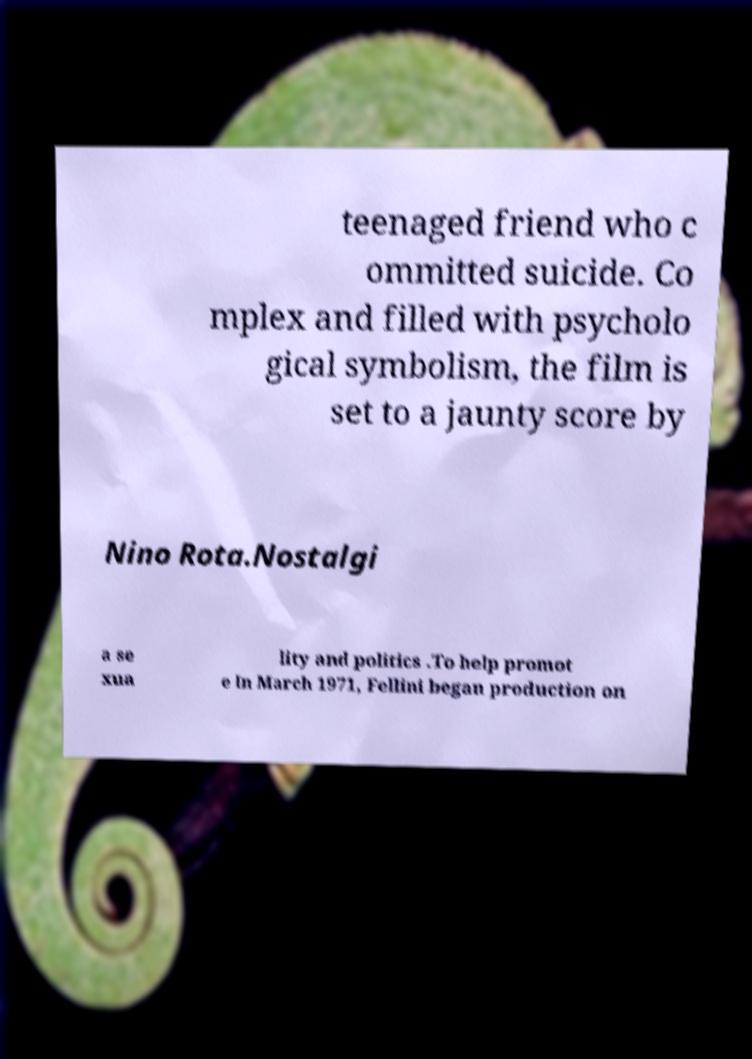Could you extract and type out the text from this image? teenaged friend who c ommitted suicide. Co mplex and filled with psycholo gical symbolism, the film is set to a jaunty score by Nino Rota.Nostalgi a se xua lity and politics .To help promot e In March 1971, Fellini began production on 